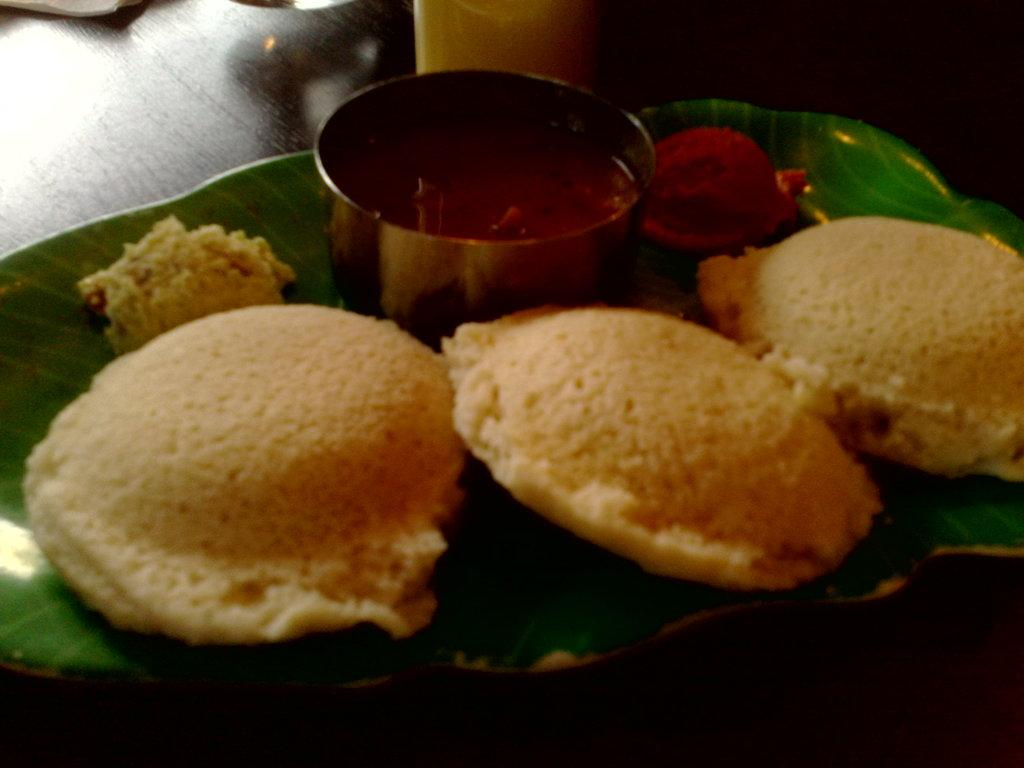How many idlis are visible in the image? There are three idlis in the image. What accompanies the idlis in the image? There is a chutney bowl in the image. What is the color of the plate on which the idlis are placed? The plate is green in color. What type of pen can be seen being used to write on the idlis in the image? There is no pen present in the image, nor are the idlis being written on. 